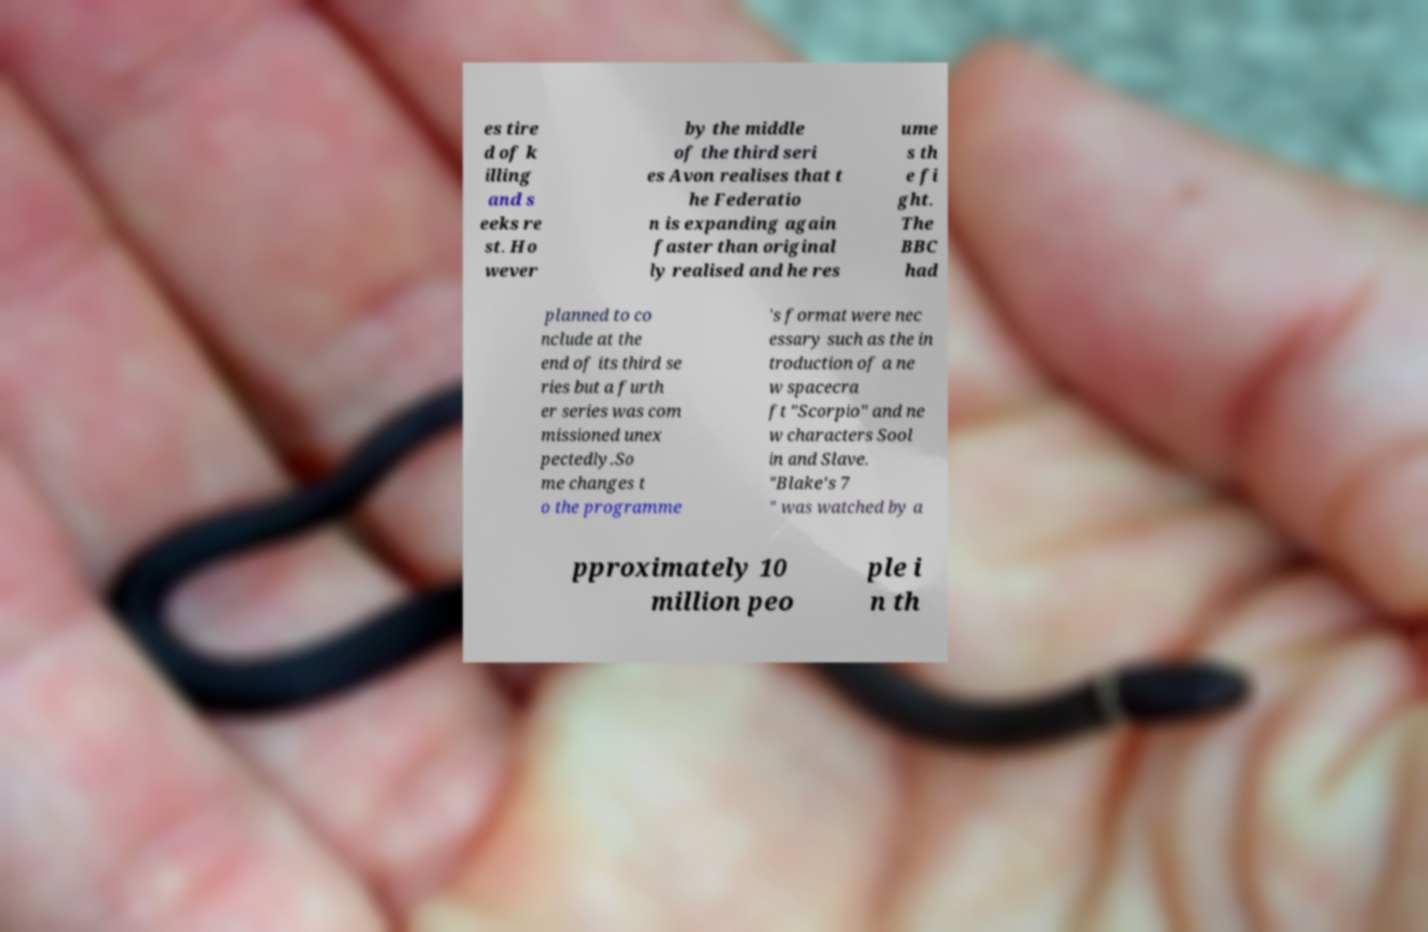For documentation purposes, I need the text within this image transcribed. Could you provide that? es tire d of k illing and s eeks re st. Ho wever by the middle of the third seri es Avon realises that t he Federatio n is expanding again faster than original ly realised and he res ume s th e fi ght. The BBC had planned to co nclude at the end of its third se ries but a furth er series was com missioned unex pectedly.So me changes t o the programme 's format were nec essary such as the in troduction of a ne w spacecra ft "Scorpio" and ne w characters Sool in and Slave. "Blake's 7 " was watched by a pproximately 10 million peo ple i n th 